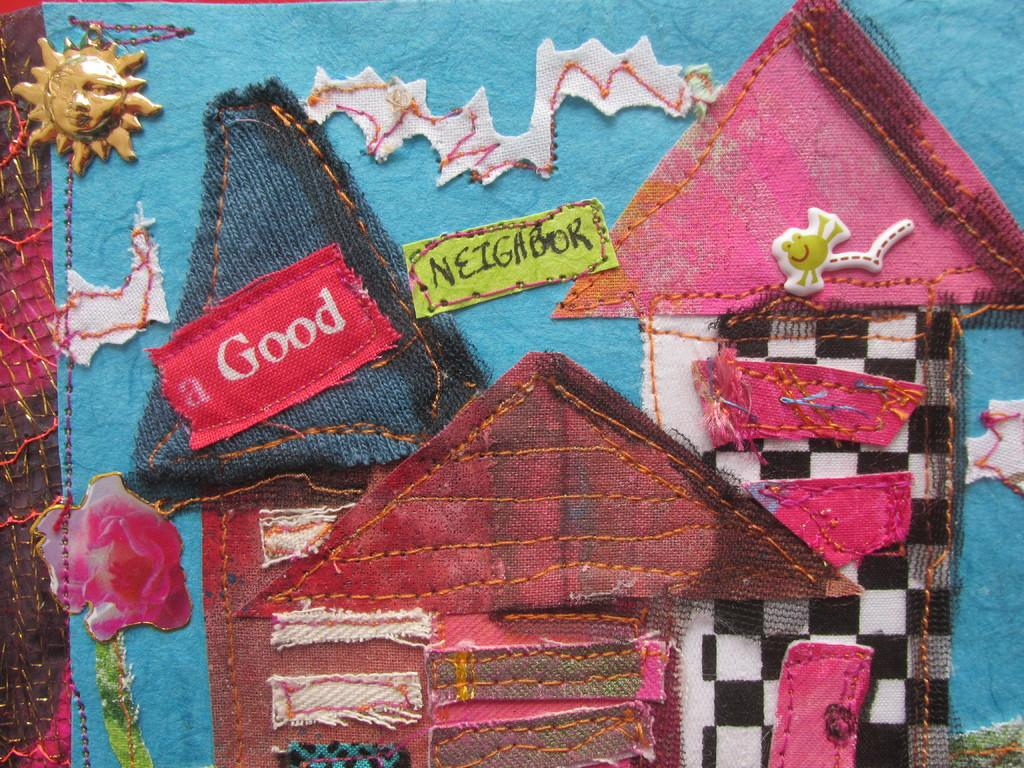What is the main subject of the image? The main subject of the image is a cloth with designs. What types of designs can be seen on the cloth? The designs include buildings, names, a bird, and a door. Are there any other objects or items in the image? Yes, there is a locket in the image. How does the bird in the image earn its income? The image does not depict a living bird, nor does it provide information about the bird's income. 